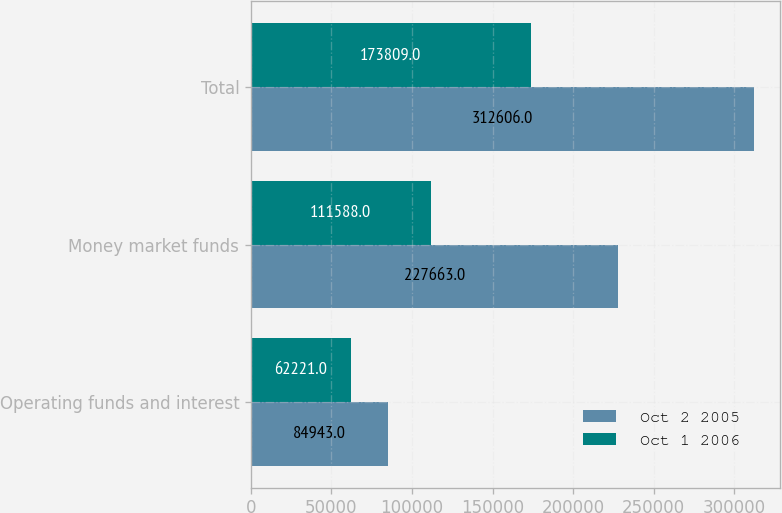Convert chart. <chart><loc_0><loc_0><loc_500><loc_500><stacked_bar_chart><ecel><fcel>Operating funds and interest<fcel>Money market funds<fcel>Total<nl><fcel>Oct 2 2005<fcel>84943<fcel>227663<fcel>312606<nl><fcel>Oct 1 2006<fcel>62221<fcel>111588<fcel>173809<nl></chart> 